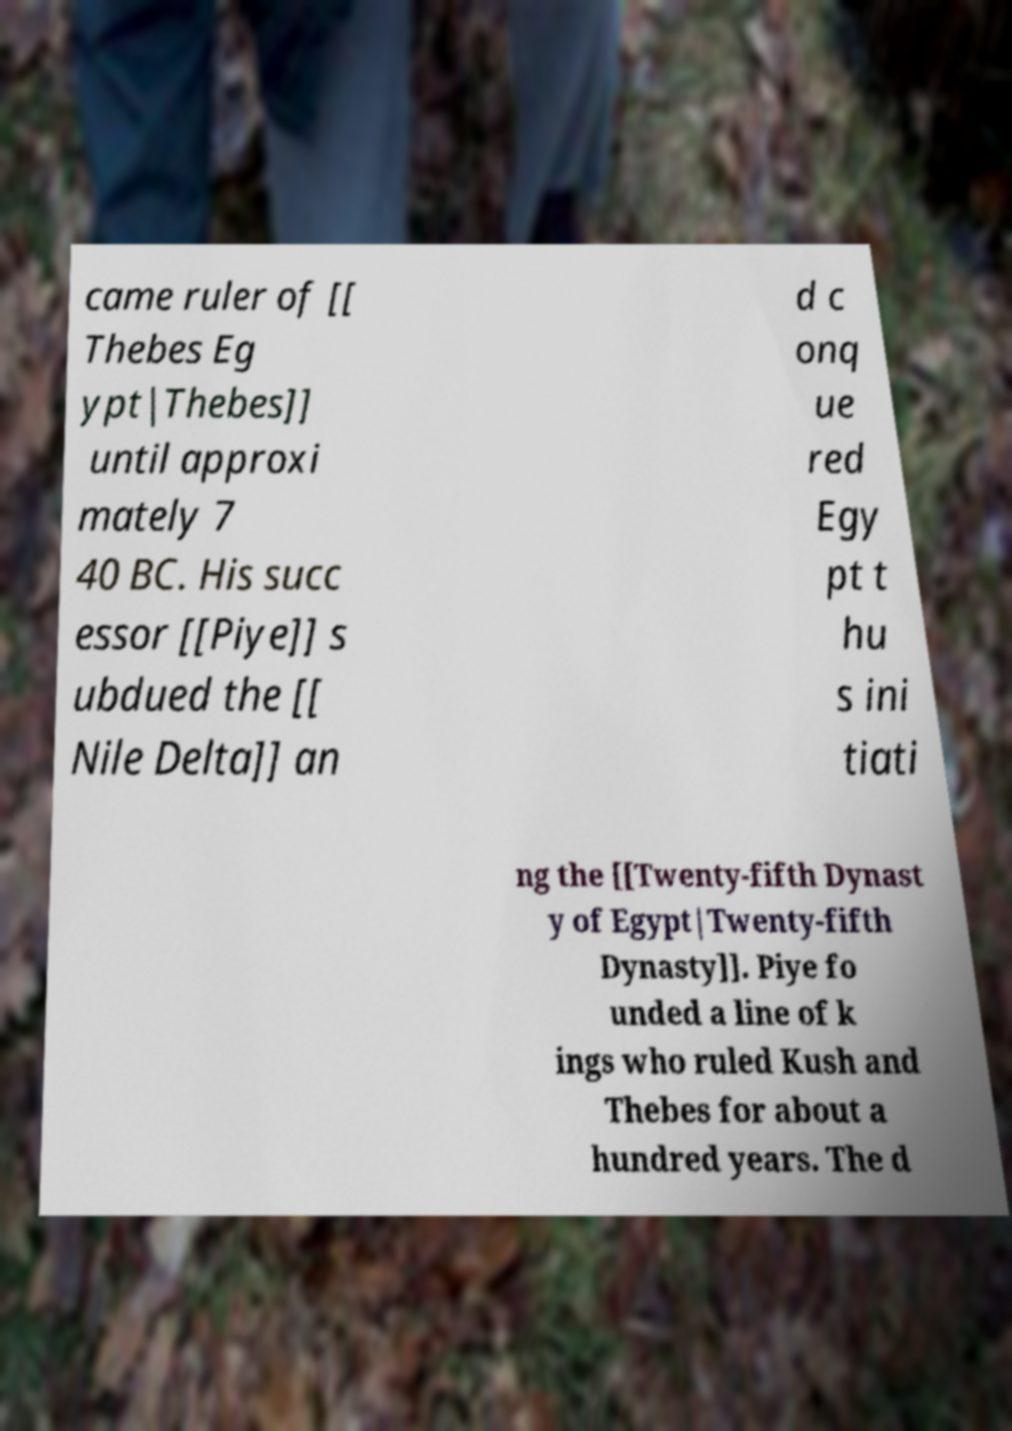Can you read and provide the text displayed in the image?This photo seems to have some interesting text. Can you extract and type it out for me? came ruler of [[ Thebes Eg ypt|Thebes]] until approxi mately 7 40 BC. His succ essor [[Piye]] s ubdued the [[ Nile Delta]] an d c onq ue red Egy pt t hu s ini tiati ng the [[Twenty-fifth Dynast y of Egypt|Twenty-fifth Dynasty]]. Piye fo unded a line of k ings who ruled Kush and Thebes for about a hundred years. The d 